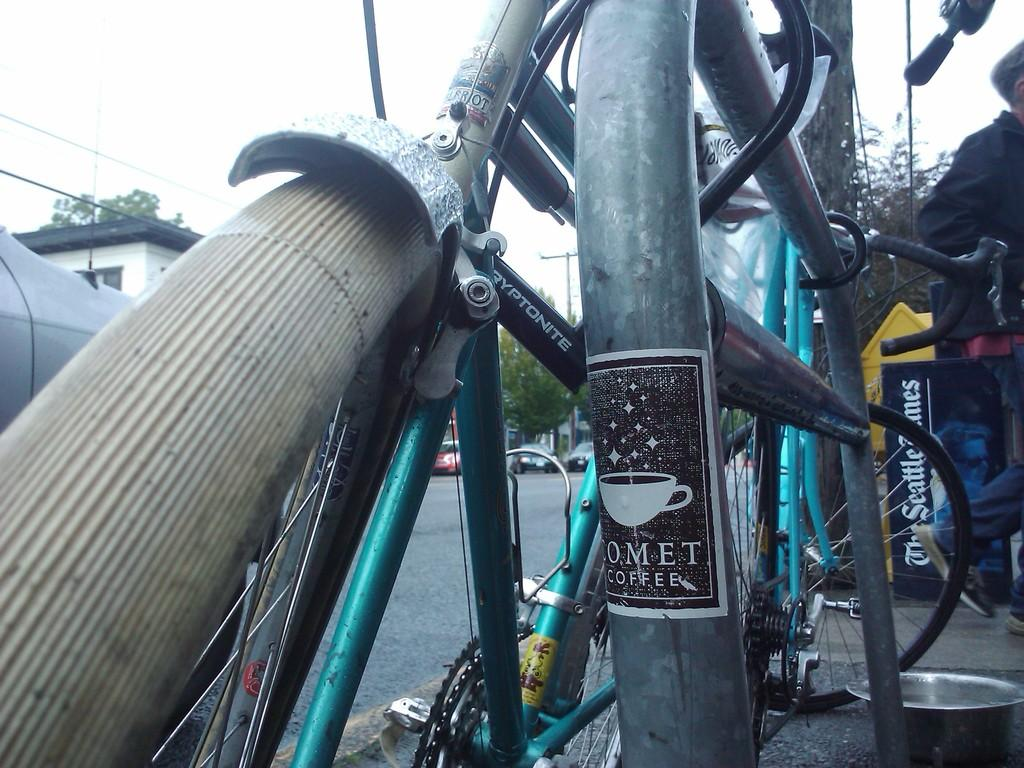What is the main object in the image? There is a bicycle in the image. What can be seen in the background of the image? There are trees visible in the image. What type of vehicles are on the road in the image? There are cars on the road in the image. Can you describe the person on the right-hand side of the image? There is a person on the right-hand side of the image. What type of buildings are on the left-hand side of the image? There are houses on the left-hand side of the image. Where is the bomb located in the image? There is no bomb present in the image. What type of animals can be seen at the zoo in the image? There is no zoo present in the image. 